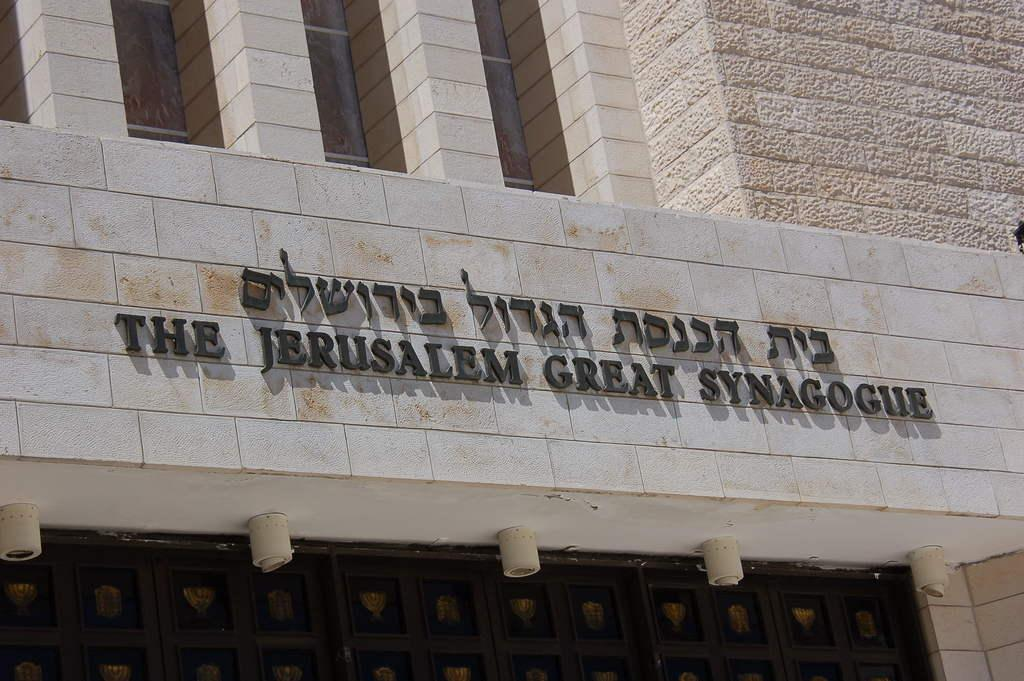What type of structure is visible in the image? There is a building in the image. Can you describe any additional features of the building? There is text on the building. How many passengers are visible in the image? There are no passengers present in the image; it only features a building with text on it. Can you fold the building in the image? No, the building cannot be folded, as it is a physical structure. 